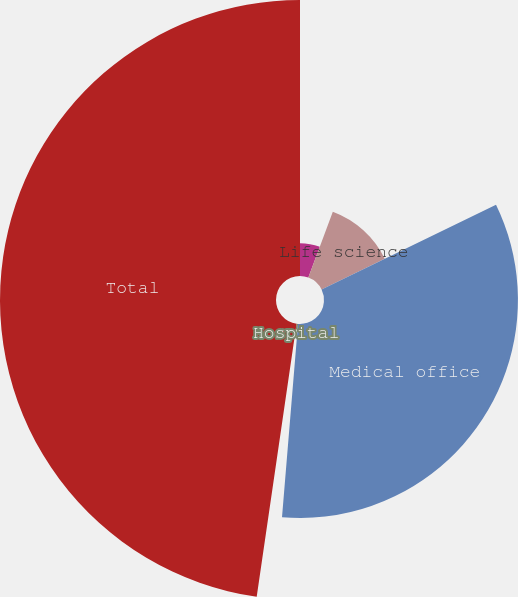Convert chart to OTSL. <chart><loc_0><loc_0><loc_500><loc_500><pie_chart><fcel>Senior housing<fcel>Life science<fcel>Medical office<fcel>Hospital<fcel>Total<nl><fcel>5.66%<fcel>12.14%<fcel>33.51%<fcel>0.99%<fcel>47.69%<nl></chart> 